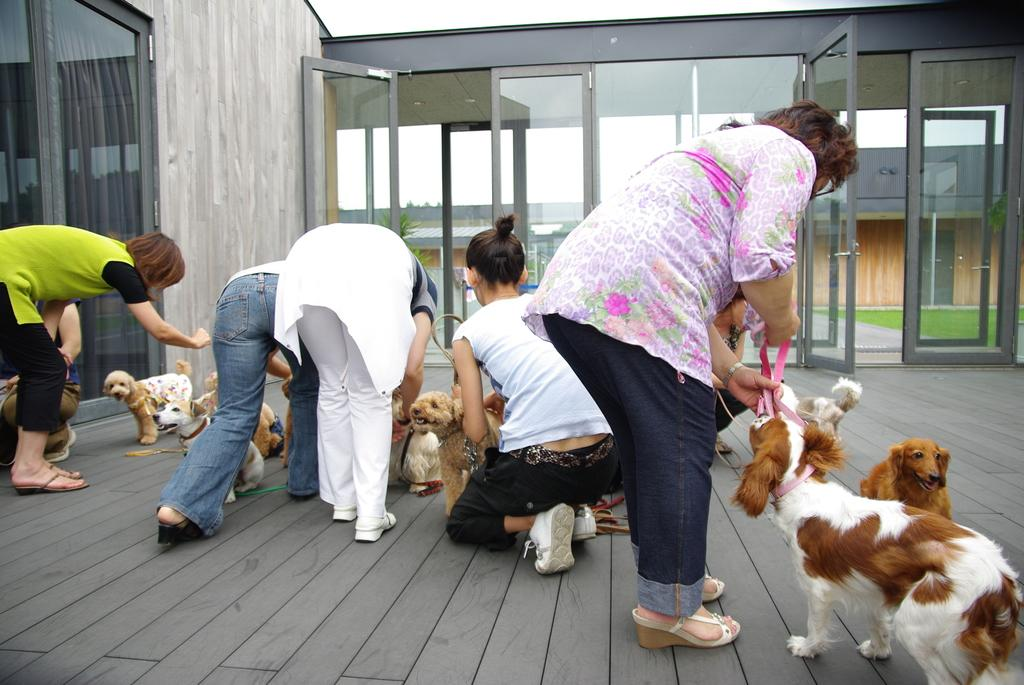Who is present in the image? There are women in the image. What are the women doing in the image? The women are leaning forward and holding dogs. What is the floor made of in the image? The floor is made of wood. What can be seen in the background of the image? There are glass walls in the background. What type of dinner is being served in the image? There is no dinner present in the image; it features women holding dogs. What do the women regret in the image? There is no indication of regret in the image; the women are holding dogs and leaning forward. 